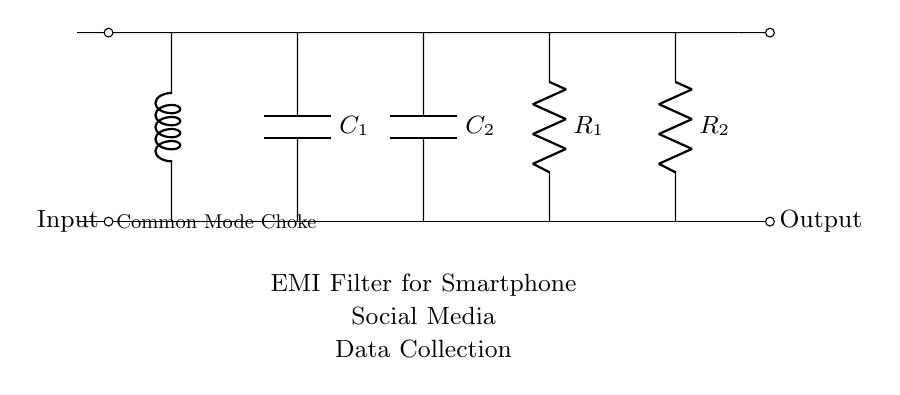What type of inductor is shown in this circuit? The circuit includes a common mode choke, as labeled alongside the inductor symbol connecting the input and output.
Answer: Common Mode Choke What components are present in the EMI filter circuit? The circuit features a common mode choke, two capacitors, and two resistors, which are labeled in the diagram.
Answer: Common mode choke, capacitors, resistors How many capacitors are used in this filter circuit? The diagram indicates the presence of two capacitors, as indicated by the labeling of C1 and C2.
Answer: Two What is the purpose of a common mode choke in this circuit? The common mode choke is designed to suppress electromagnetic interference by allowing differential signals to pass while blocking common-mode noise.
Answer: Suppress electromagnetic interference What is the order of components from input to output in this EMI filter? The order is: input, common mode choke, C1, C2, R1, R2, and then output; this shows the sequential flow of electrical signals.
Answer: Input, common mode choke, C1, C2, R1, R2, output What is the labeling of the resistors in the circuit? The two resistors are labeled as R1 and R2, indicating their specific roles in the filtering process.
Answer: R1 and R2 